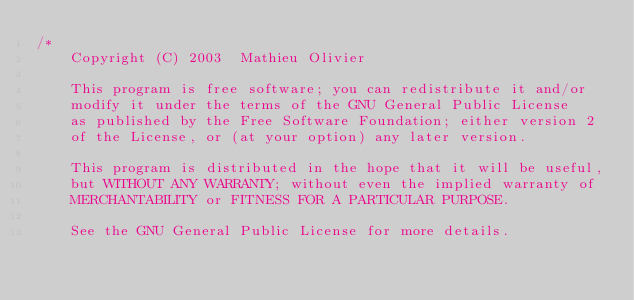<code> <loc_0><loc_0><loc_500><loc_500><_C_>/*
	Copyright (C) 2003  Mathieu Olivier

	This program is free software; you can redistribute it and/or
	modify it under the terms of the GNU General Public License
	as published by the Free Software Foundation; either version 2
	of the License, or (at your option) any later version.

	This program is distributed in the hope that it will be useful,
	but WITHOUT ANY WARRANTY; without even the implied warranty of
	MERCHANTABILITY or FITNESS FOR A PARTICULAR PURPOSE.

	See the GNU General Public License for more details.
</code> 